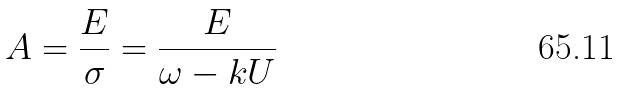Convert formula to latex. <formula><loc_0><loc_0><loc_500><loc_500>A = \frac { E } { \sigma } = \frac { E } { \omega - k U }</formula> 